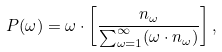<formula> <loc_0><loc_0><loc_500><loc_500>P ( \omega ) = \omega \cdot \left [ \frac { n _ { \omega } } { \sum _ { \omega = 1 } ^ { \infty } ( \omega \cdot n _ { \omega } ) } \right ] ,</formula> 